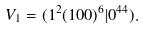<formula> <loc_0><loc_0><loc_500><loc_500>V _ { 1 } = ( 1 ^ { 2 } ( 1 0 0 ) ^ { 6 } | 0 ^ { 4 4 } ) .</formula> 